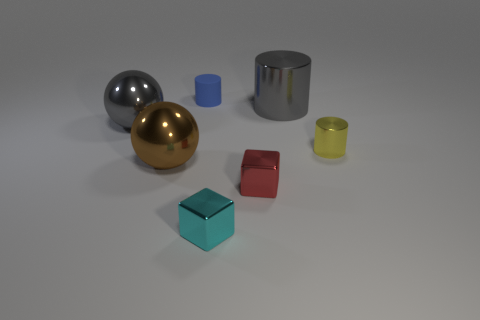What is the color of the other metallic thing that is the same shape as the red object?
Your answer should be very brief. Cyan. There is a large thing that is behind the large gray object to the left of the small cylinder that is behind the big cylinder; what shape is it?
Offer a terse response. Cylinder. Do the tiny cyan object and the rubber object have the same shape?
Offer a terse response. No. There is a big gray object behind the large ball behind the yellow shiny thing; what is its shape?
Your response must be concise. Cylinder. Are there any tiny yellow shiny objects?
Provide a short and direct response. Yes. There is a metal sphere that is to the left of the shiny sphere that is in front of the yellow cylinder; how many shiny spheres are left of it?
Keep it short and to the point. 0. There is a tiny cyan metal thing; does it have the same shape as the brown metal object that is behind the cyan shiny cube?
Offer a terse response. No. Is the number of tiny yellow metallic cylinders greater than the number of big shiny spheres?
Offer a very short reply. No. There is a thing in front of the red thing; does it have the same shape as the tiny red thing?
Give a very brief answer. Yes. Is the number of metal things right of the tiny rubber cylinder greater than the number of small cyan cubes?
Offer a terse response. Yes. 